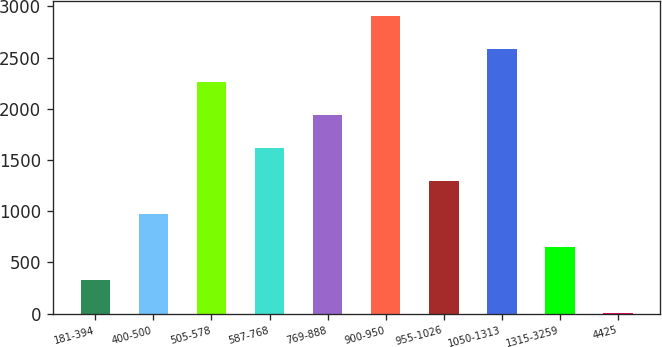Convert chart. <chart><loc_0><loc_0><loc_500><loc_500><bar_chart><fcel>181-394<fcel>400-500<fcel>505-578<fcel>587-768<fcel>769-888<fcel>900-950<fcel>955-1026<fcel>1050-1313<fcel>1315-3259<fcel>4425<nl><fcel>323.7<fcel>969.1<fcel>2259.9<fcel>1614.5<fcel>1937.2<fcel>2905.3<fcel>1291.8<fcel>2582.6<fcel>646.4<fcel>1<nl></chart> 